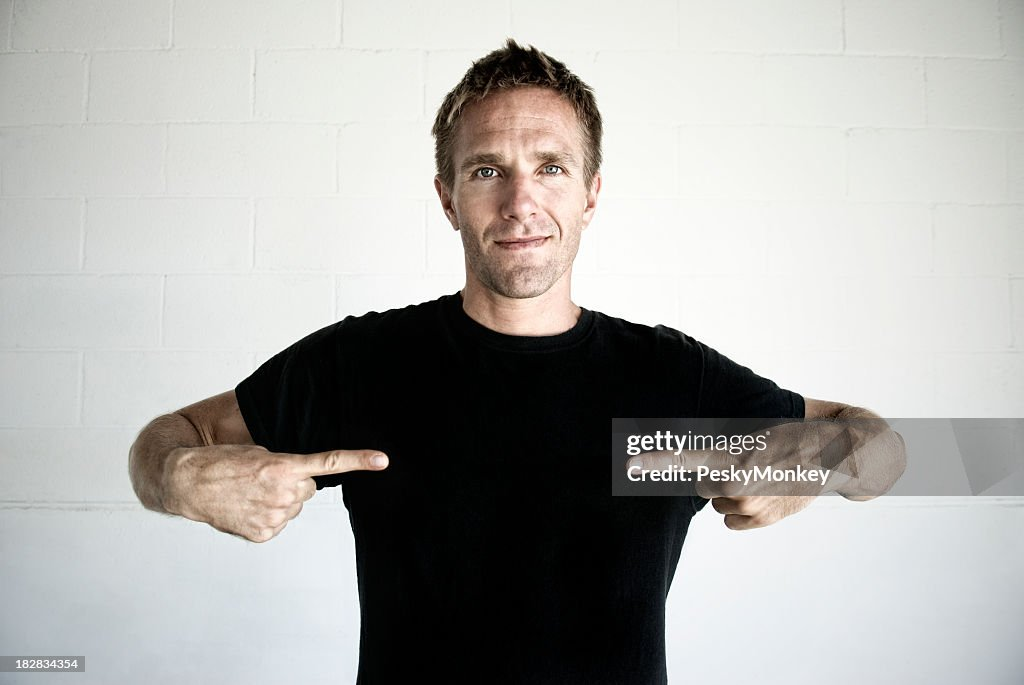What might be the context in which the man is pointing to himself, and what could he possibly be indicating or promoting? Based solely on the image, the context in which the man is pointing to himself could be multifaceted. The gesture could be interpreted as self-referential, possibly indicating pride or ownership in his personal identity or achievements. It may also be part of a larger communicative act, such as in a presentation or an advertisement where he is the focal point. The plain black T-shirt serves as a neutral canvas, which suggests that the focus is meant to be on him or a message related to him, rather than on any text or imagery that could have been on the shirt. Without additional context or text, it is not possible to determine exactly what he is promoting or indicating, but it is clear that he is drawing attention to himself in a positive and confident manner. 